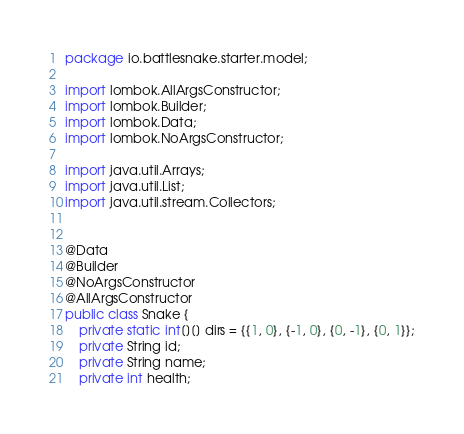Convert code to text. <code><loc_0><loc_0><loc_500><loc_500><_Java_>package io.battlesnake.starter.model;

import lombok.AllArgsConstructor;
import lombok.Builder;
import lombok.Data;
import lombok.NoArgsConstructor;

import java.util.Arrays;
import java.util.List;
import java.util.stream.Collectors;


@Data
@Builder
@NoArgsConstructor
@AllArgsConstructor
public class Snake {
    private static int[][] dirs = {{1, 0}, {-1, 0}, {0, -1}, {0, 1}};
    private String id;
    private String name;
    private int health;</code> 